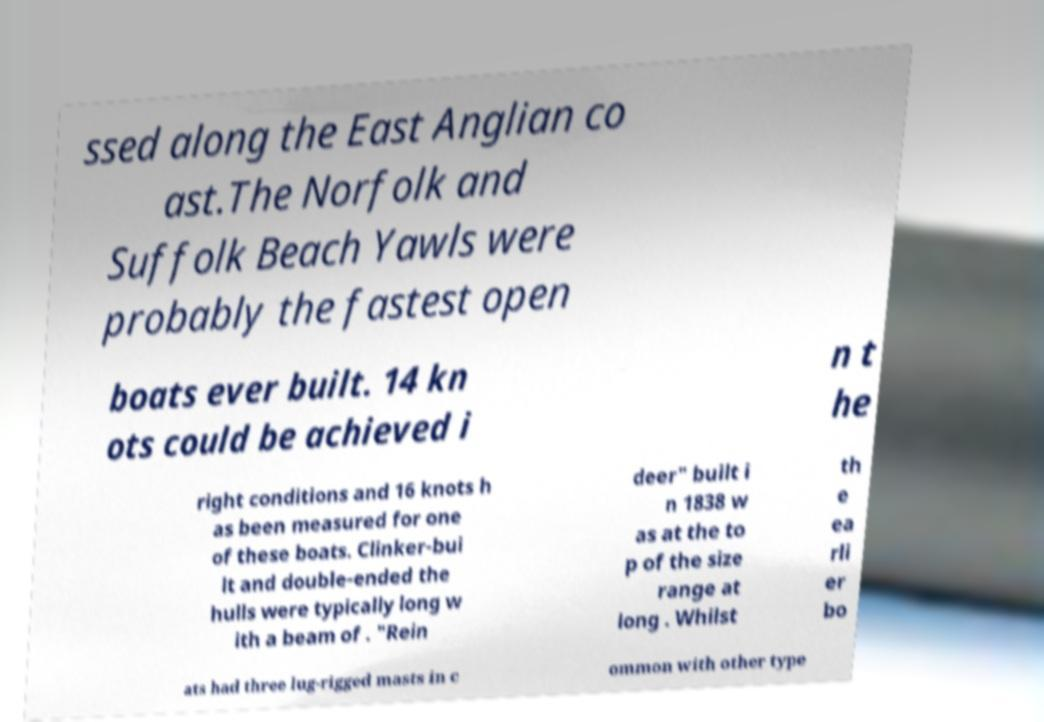Please read and relay the text visible in this image. What does it say? ssed along the East Anglian co ast.The Norfolk and Suffolk Beach Yawls were probably the fastest open boats ever built. 14 kn ots could be achieved i n t he right conditions and 16 knots h as been measured for one of these boats. Clinker-bui lt and double-ended the hulls were typically long w ith a beam of . "Rein deer" built i n 1838 w as at the to p of the size range at long . Whilst th e ea rli er bo ats had three lug-rigged masts in c ommon with other type 